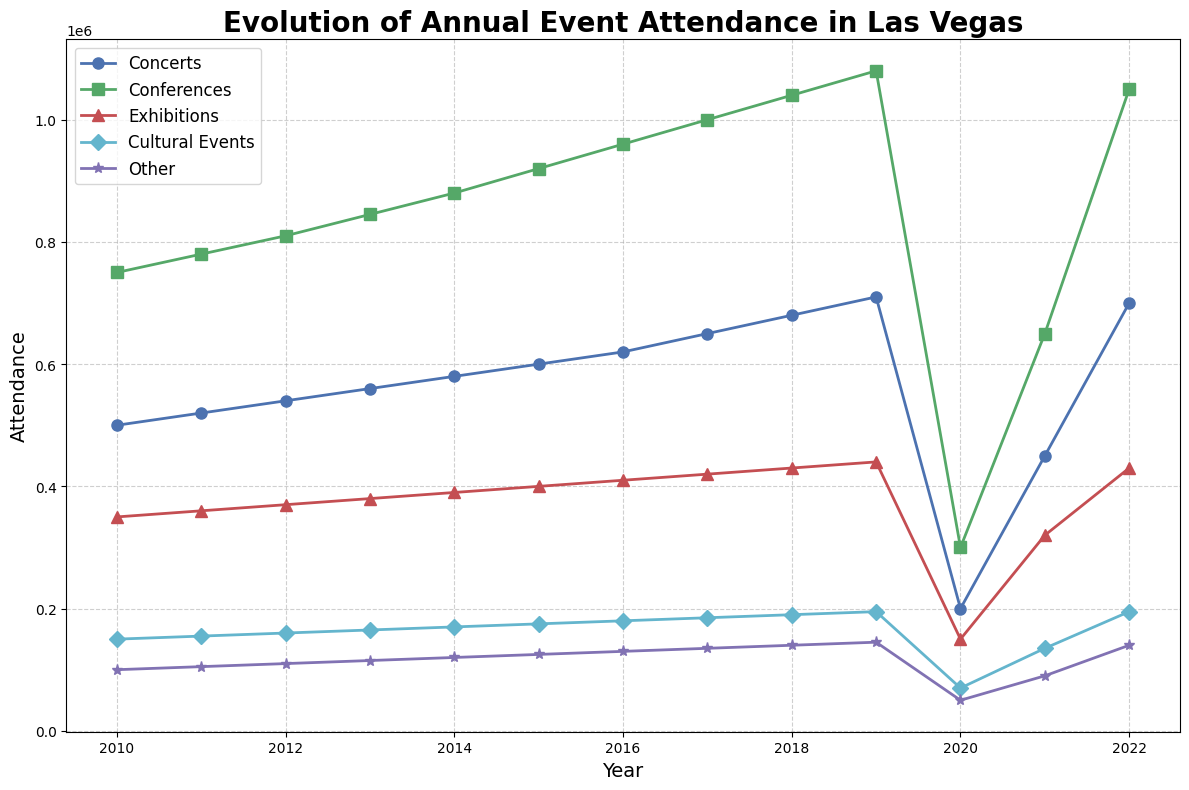What's the trend in attendance for conferences between 2010 and 2019? From 2010 to 2019, the attendance for conferences consistently increases each year. In 2010, the attendance was 750,000, and it climbed to 1,080,000 by 2019. This consistent rise shows a positive trend.
Answer: Positive trend Which year showed the lowest attendance for concerts, and what was the attendance figure? Looking at the chart, the lowest attendance for concerts occurred in 2020. The attendance for that year was 200,000. This is a drop compared to other years.
Answer: 2020, 200,000 Compare the attendance for cultural events and exhibitions in 2021. Which one had higher attendance? In 2021, the attendance for cultural events was 135,000, whereas the attendance for exhibitions was 320,000. Comparatively, exhibitions had higher attendance.
Answer: Exhibitions What was the cumulative increase in attendance for concerts from 2010 to 2017? Attendance in 2010 was 500,000, and by 2017, it was 650,000. The increase can be calculated as 650,000 - 500,000 = 150,000.
Answer: 150,000 In which year did 'Other' events reach their peak attendance, and what was the figure? The chart shows that 'Other' events reached their peak attendance in 2019 with a figure of 145,000.
Answer: 2019, 145,000 Comparing 2020 and 2022, how much did the conferences' attendance change? In 2020, the attendance for conferences was 300,000 and in 2022, it was 1,050,000. The change was 1,050,000 - 300,000 = 750,000.
Answer: 750,000 What can you say about the attendance for cultural events over time? The attendance for cultural events started at 150,000 in 2010 and had a generally increasing trend, reaching 195,000 by 2019. There was a significant drop to 70,000 in 2020 but it recovered afterward to 195,000 by 2022.
Answer: Generally increasing How did the attendance for 'Other' events change from 2020 to 2022? In 2020, the attendance was 50,000, and in 2022, it was 140,000. So, the change is 140,000 - 50,000 = 90,000.
Answer: 90,000 Between concerts and exhibitions, which had a more dramatic drop in attendance in 2020 compared to 2019? For concerts, the attendance dropped from 710,000 in 2019 to 200,000 in 2020, a difference of 510,000. For exhibitions, the drop was from 440,000 in 2019 to 150,000 in 2020, a difference of 290,000. Therefore, concerts had a more dramatic drop.
Answer: Concerts Which event category shows the most stable growth pattern from 2010 to 2019? Looking at the lines for each category, conferences show the most stable growth, with a consistent rise in attendance from 750,000 in 2010 to 1,080,000 in 2019 without any sudden drops or increases.
Answer: Conferences 